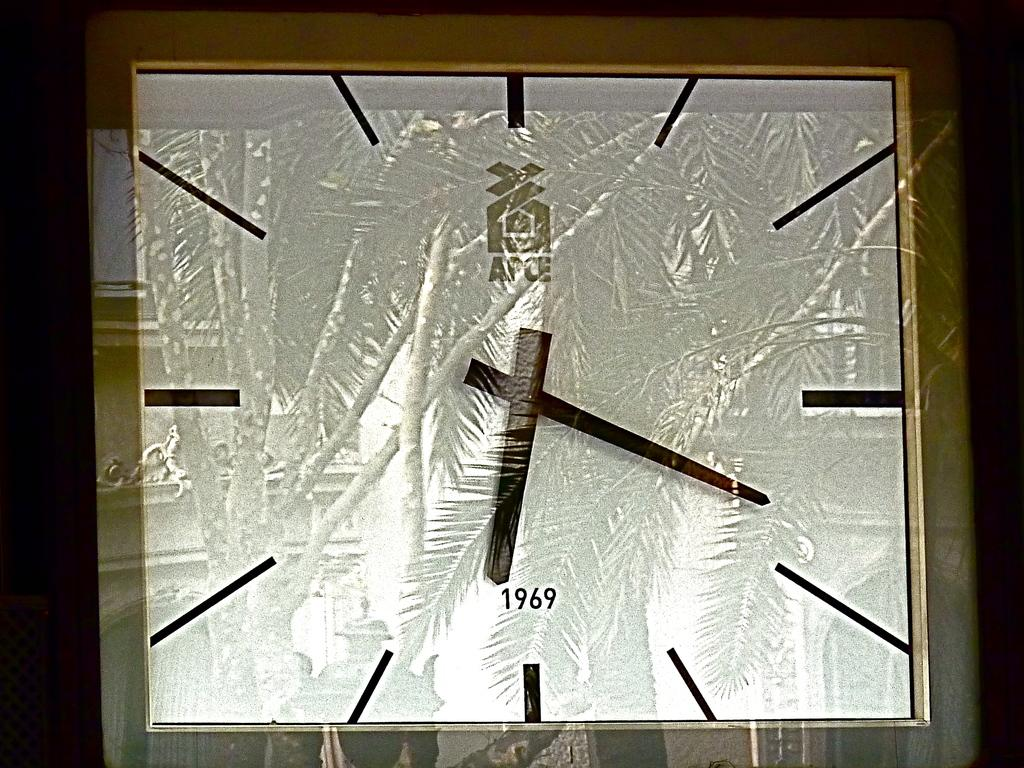<image>
Present a compact description of the photo's key features. A photo of an APCE analog clock with 1969 on it. 